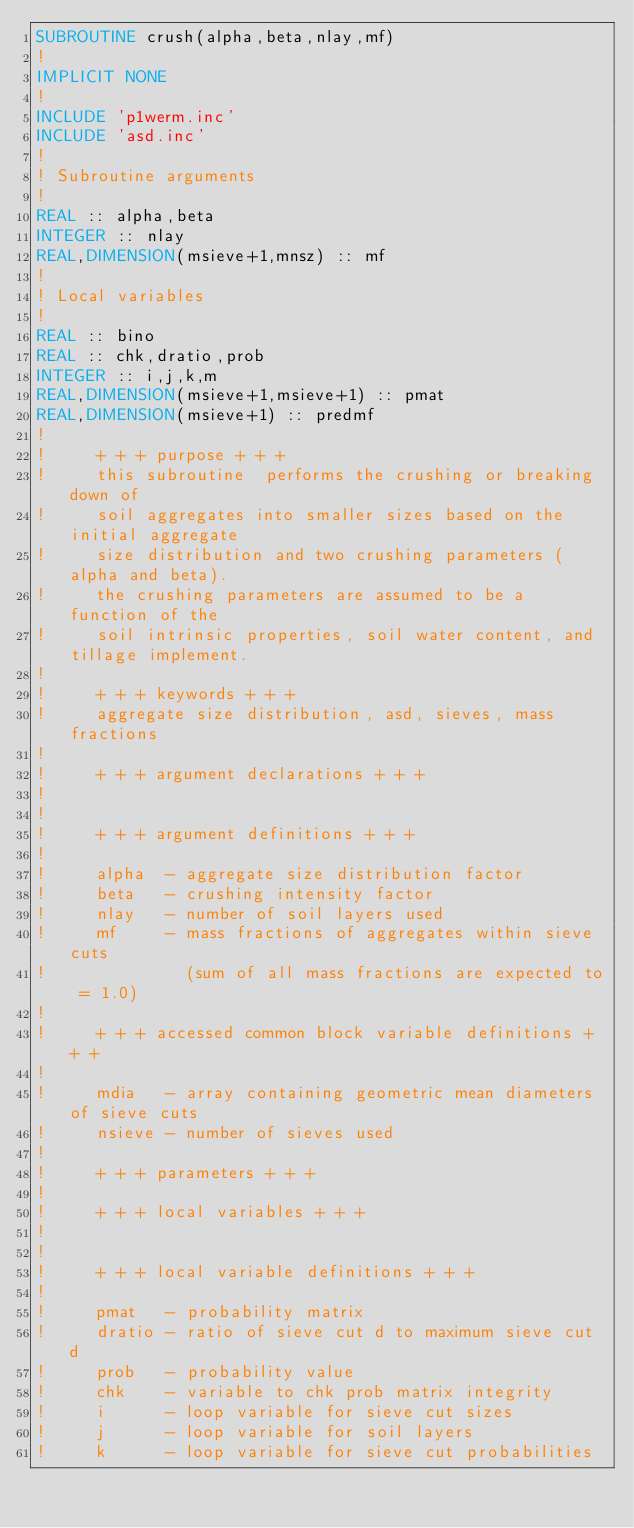Convert code to text. <code><loc_0><loc_0><loc_500><loc_500><_FORTRAN_>SUBROUTINE crush(alpha,beta,nlay,mf)
!
IMPLICIT NONE
!
INCLUDE 'p1werm.inc'
INCLUDE 'asd.inc'
!
! Subroutine arguments
!
REAL :: alpha,beta
INTEGER :: nlay
REAL,DIMENSION(msieve+1,mnsz) :: mf
!
! Local variables
!
REAL :: bino
REAL :: chk,dratio,prob
INTEGER :: i,j,k,m
REAL,DIMENSION(msieve+1,msieve+1) :: pmat
REAL,DIMENSION(msieve+1) :: predmf
!
!     + + + purpose + + +
!     this subroutine  performs the crushing or breaking down of
!     soil aggregates into smaller sizes based on the initial aggregate
!     size distribution and two crushing parameters (alpha and beta).
!     the crushing parameters are assumed to be a function of the
!     soil intrinsic properties, soil water content, and tillage implement.
!
!     + + + keywords + + +
!     aggregate size distribution, asd, sieves, mass fractions
!
!     + + + argument declarations + + +
!
!
!     + + + argument definitions + + +
!
!     alpha  - aggregate size distribution factor
!     beta   - crushing intensity factor
!     nlay   - number of soil layers used
!     mf     - mass fractions of aggregates within sieve cuts
!              (sum of all mass fractions are expected to = 1.0)
!
!     + + + accessed common block variable definitions + + +
!
!     mdia   - array containing geometric mean diameters of sieve cuts
!     nsieve - number of sieves used
!
!     + + + parameters + + +
!
!     + + + local variables + + +
!
!
!     + + + local variable definitions + + +
!
!     pmat   - probability matrix
!     dratio - ratio of sieve cut d to maximum sieve cut d
!     prob   - probability value
!     chk    - variable to chk prob matrix integrity
!     i      - loop variable for sieve cut sizes
!     j      - loop variable for soil layers
!     k      - loop variable for sieve cut probabilities</code> 